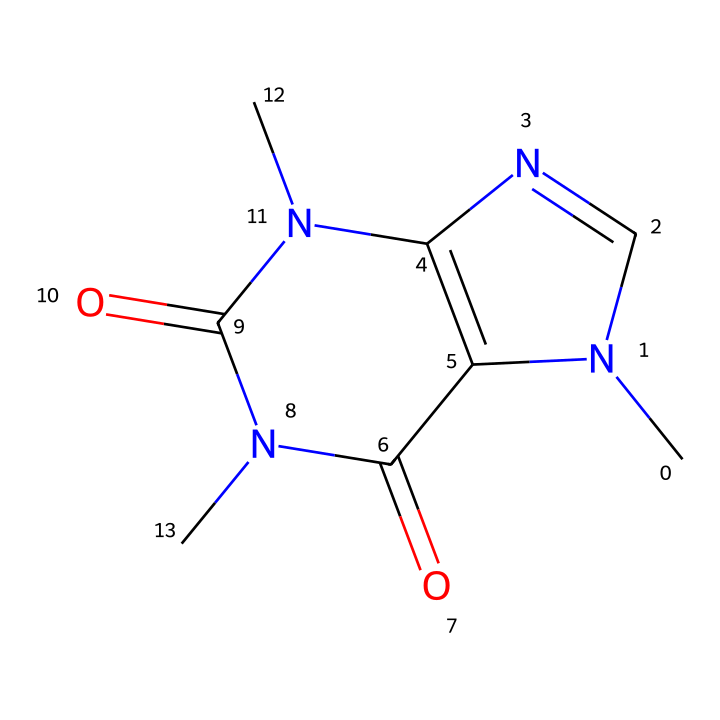What is the molecular formula of caffeine? By analyzing the SMILES representation, we can count the number of each atom present. The formula for caffeine is determined to be C8H10N4O2, indicating it contains 8 carbon (C), 10 hydrogen (H), 4 nitrogen (N), and 2 oxygen (O) atoms.
Answer: C8H10N4O2 How many nitrogen atoms are in the caffeine structure? The SMILES representation includes the letter 'N', which signifies nitrogen atoms. Counting these, we find there are four nitrogen (N) atoms in total.
Answer: 4 What type of chemical compound is caffeine classified as? Caffeine exhibits properties typical of alkaloids due to its nitrogen-containing structure and physiological effects. Analyzing the arrangement includes rings and nitrogen atoms characteristic of alkaloids.
Answer: alkaloid What are the ring structures present in caffeine? Upon examining the SMILES code, the structure reveals two interconnected rings. This can be recognized through the subscripted numbers indicating which atoms are connected in a cyclic arrangement.
Answer: two What is the conjugation present in the caffeine structure? The structure features alternating single and double bonds within the rings. This conjugation allows for delocalization of electrons, which is key for the molecule's stability and functional properties.
Answer: alternating bonds How many carbon atoms are in the caffeine molecule? In the SMILES notation, the presence of 'C' indicates the carbon atoms present in the structure. Counting these, we find there are eight carbon (C) atoms in the caffeine molecule.
Answer: 8 